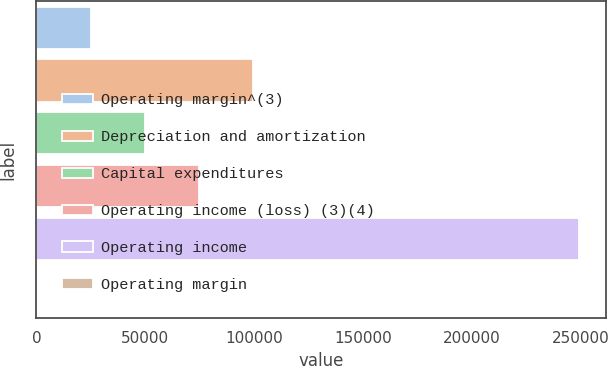Convert chart. <chart><loc_0><loc_0><loc_500><loc_500><bar_chart><fcel>Operating margin^(3)<fcel>Depreciation and amortization<fcel>Capital expenditures<fcel>Operating income (loss) (3)(4)<fcel>Operating income<fcel>Operating margin<nl><fcel>24926.5<fcel>99656.3<fcel>49836.4<fcel>74746.4<fcel>249116<fcel>16.5<nl></chart> 